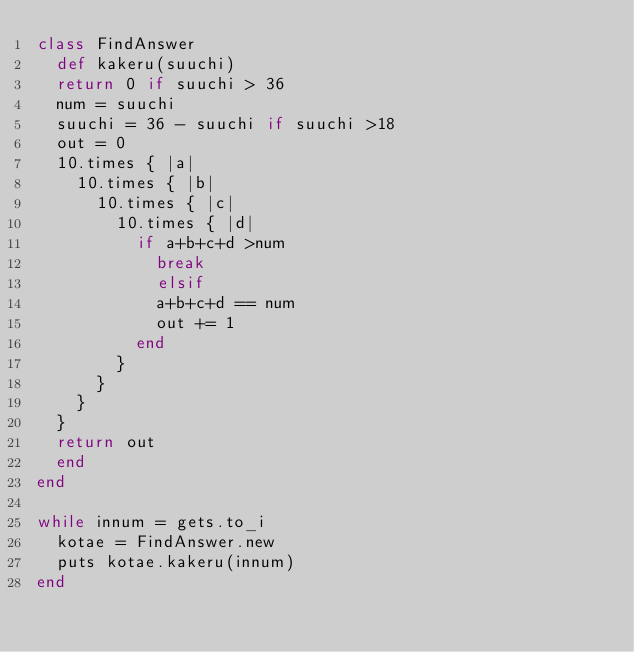<code> <loc_0><loc_0><loc_500><loc_500><_Ruby_>class FindAnswer
	def kakeru(suuchi)
	return 0 if suuchi > 36
	num = suuchi
	suuchi = 36 - suuchi if suuchi >18
	out = 0
	10.times { |a|
		10.times { |b|
			10.times { |c|
				10.times { |d|
					if a+b+c+d >num
						break
						elsif
						a+b+c+d == num
						out += 1
					end
				}
			}
		}
	}
	return out
	end
end

while innum = gets.to_i
	kotae = FindAnswer.new
	puts kotae.kakeru(innum)
end</code> 